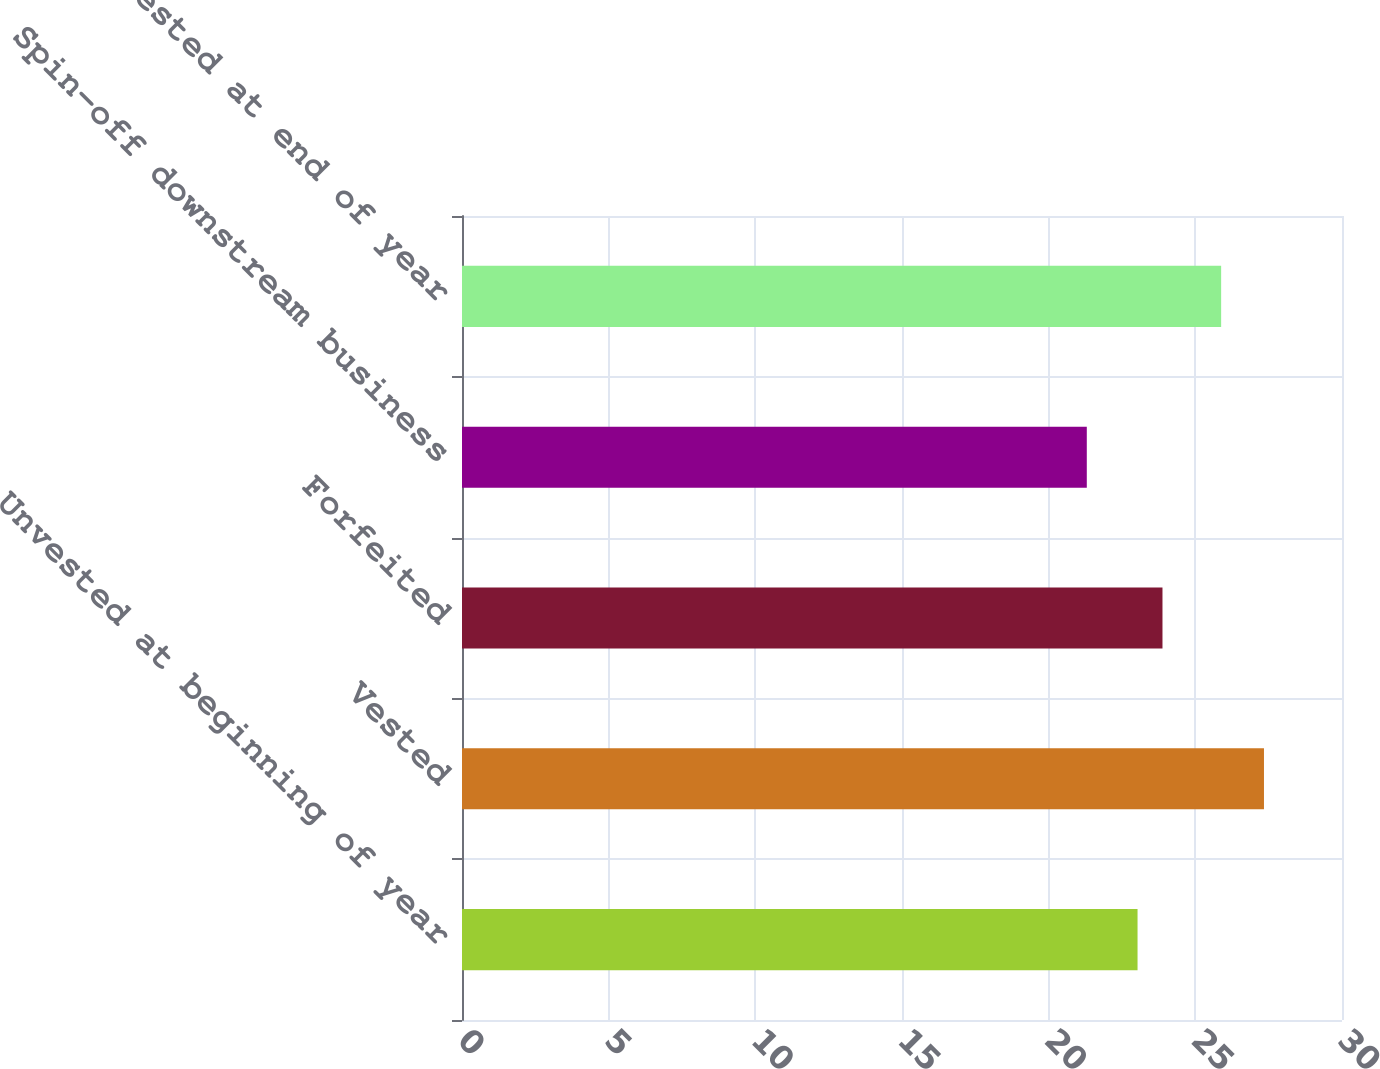Convert chart. <chart><loc_0><loc_0><loc_500><loc_500><bar_chart><fcel>Unvested at beginning of year<fcel>Vested<fcel>Forfeited<fcel>Spin-off downstream business<fcel>Unvested at end of year<nl><fcel>23.03<fcel>27.34<fcel>23.88<fcel>21.3<fcel>25.88<nl></chart> 